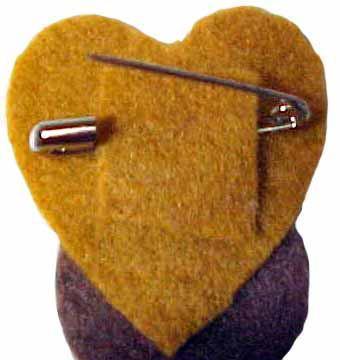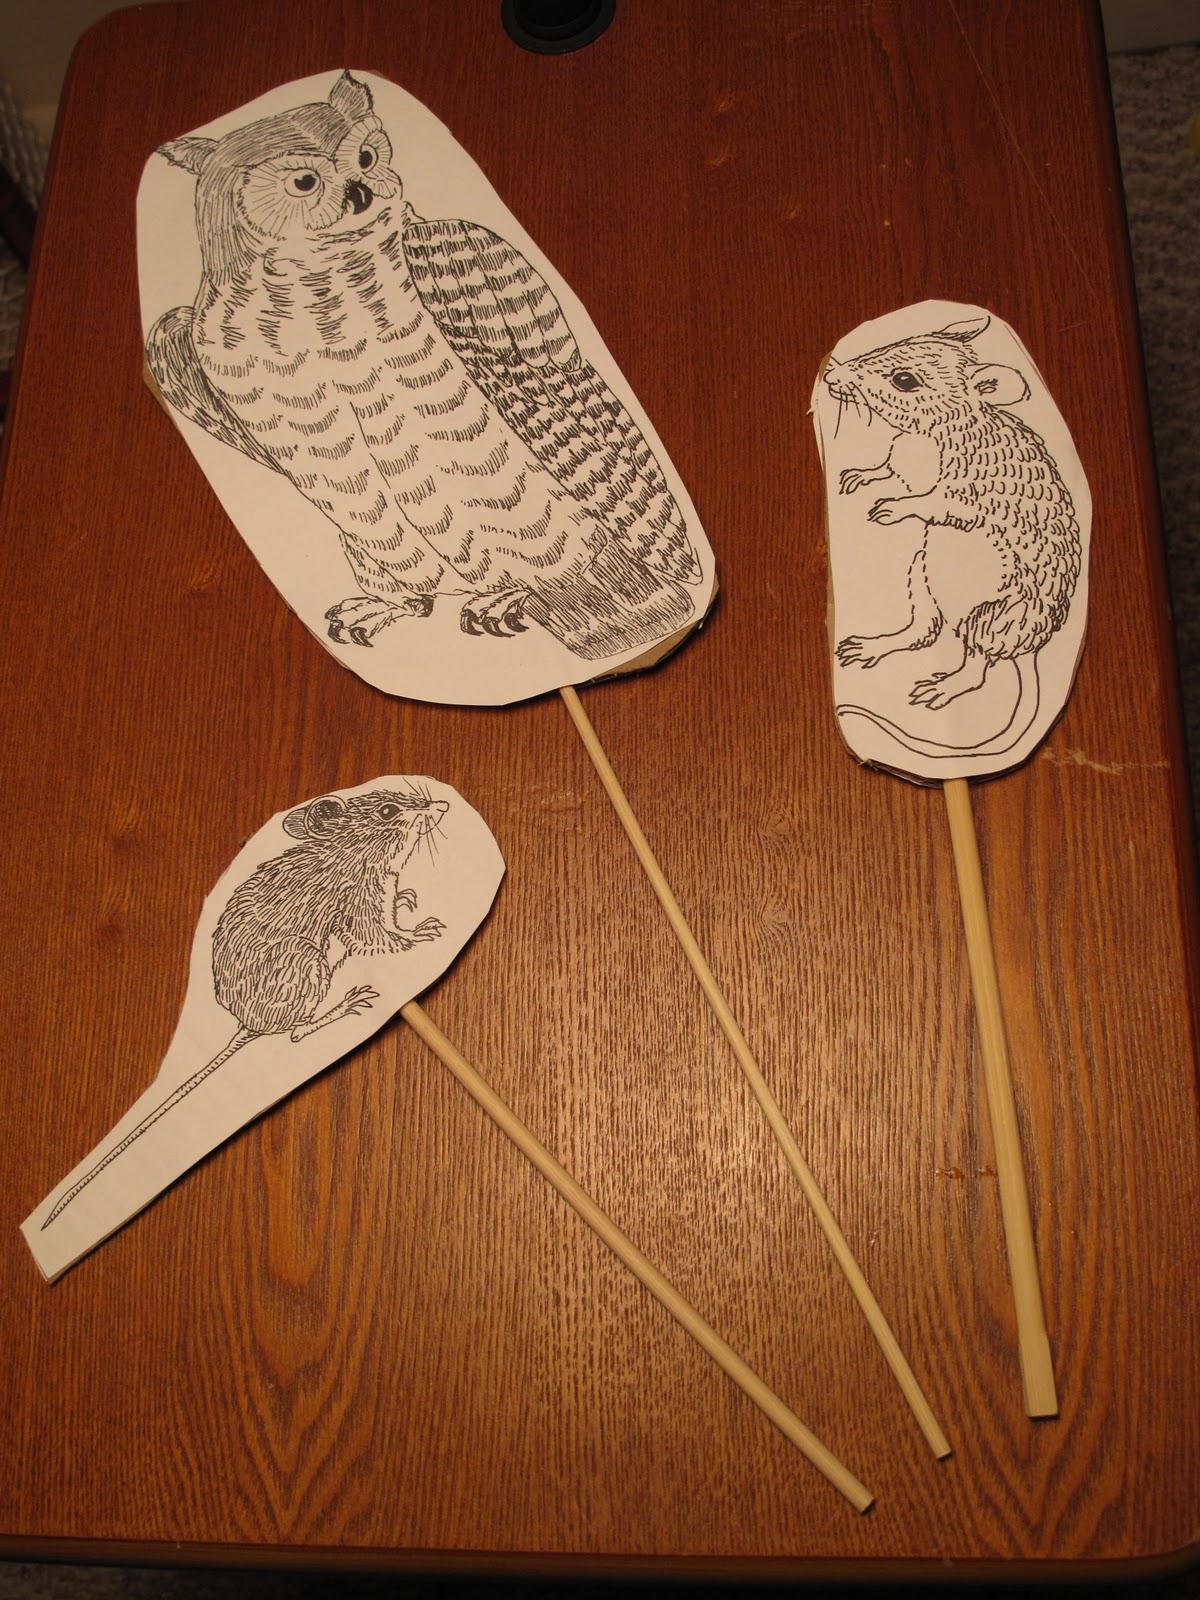The first image is the image on the left, the second image is the image on the right. Evaluate the accuracy of this statement regarding the images: "One picture features jewelry made from safety pins that is meant to be worn around one's wrist.". Is it true? Answer yes or no. No. The first image is the image on the left, the second image is the image on the right. For the images shown, is this caption "An image shows a bracelet made of one color of safety pins, strung with beads." true? Answer yes or no. No. 